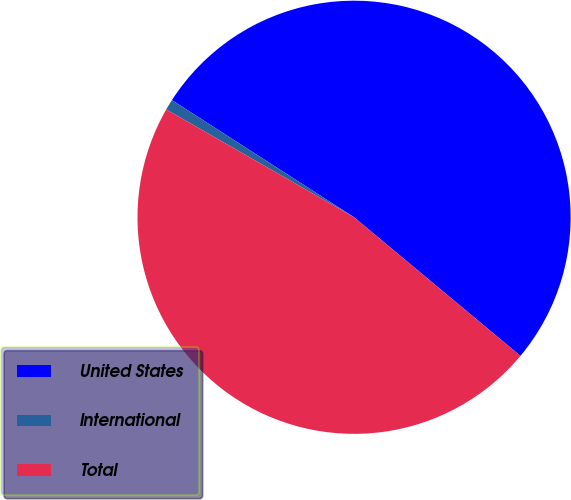Convert chart. <chart><loc_0><loc_0><loc_500><loc_500><pie_chart><fcel>United States<fcel>International<fcel>Total<nl><fcel>51.96%<fcel>0.8%<fcel>47.24%<nl></chart> 